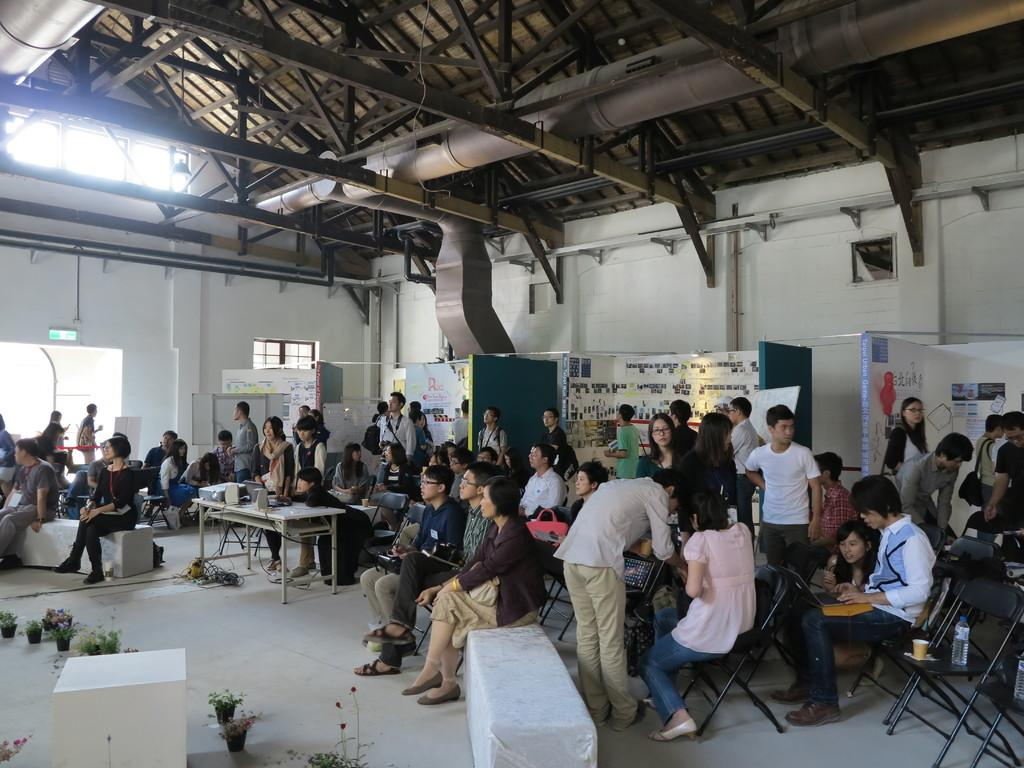How many people are in the image? There are multiple people in the image. What are some of the people doing in the image? Some of the people are sitting, and some are standing. What objects can be seen in the background of the image? There are tables, chairs, and a wall visible in the background of the image. What scientific detail can be observed in the image? There is no specific scientific detail present in the image. What causes the burst of laughter in the image? There is no laughter or burst of laughter depicted in the image. 